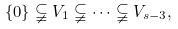Convert formula to latex. <formula><loc_0><loc_0><loc_500><loc_500>\{ 0 \} \subsetneqq V _ { 1 } \subsetneqq \dots \subsetneqq V _ { s - 3 } ,</formula> 